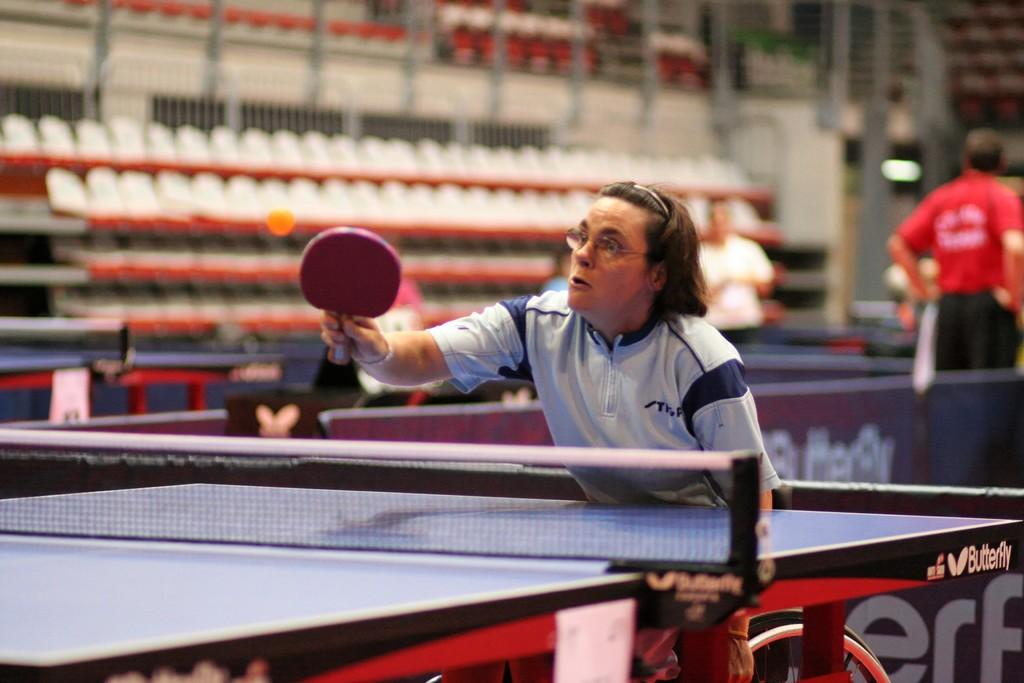What activity is the person in the image engaged in? The person is playing table tennis in the image. Where is the person positioned in relation to the table tennis table? The person is standing in front of the table tennis table. Can you describe the presence of other people in the image? There are other people in the background of the image. What type of ant can be seen in the image? There are no ants present in the image. Can you describe the zoo setting in the image? There is no zoo setting in the image; it features a person playing table tennis. 